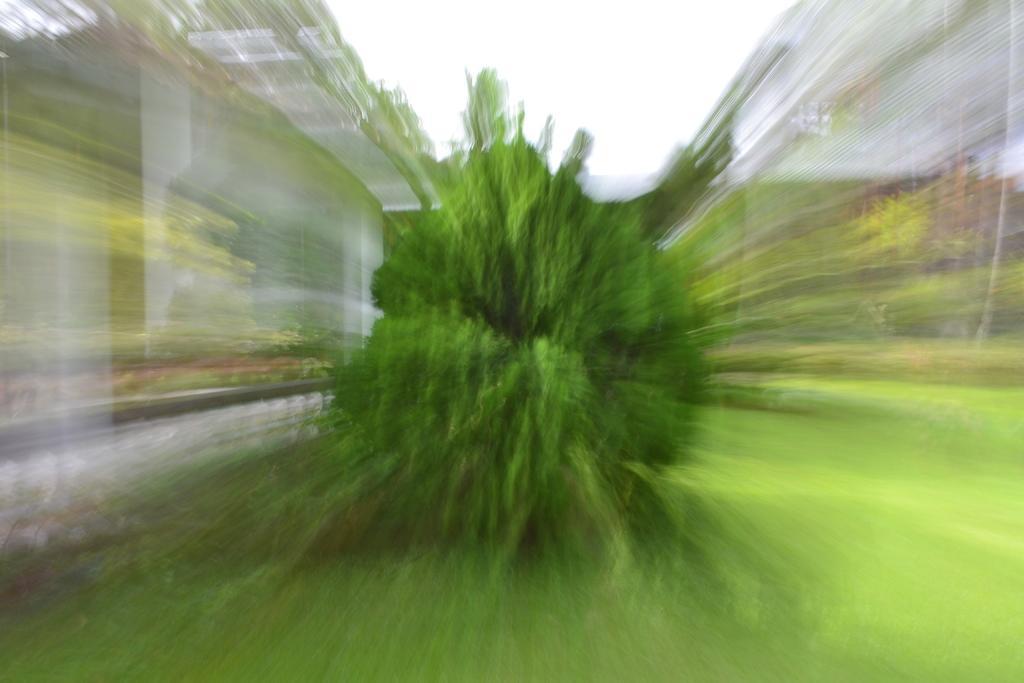Describe this image in one or two sentences. In this image, we can see a plant and the sky. The corners of the image are blurred. 